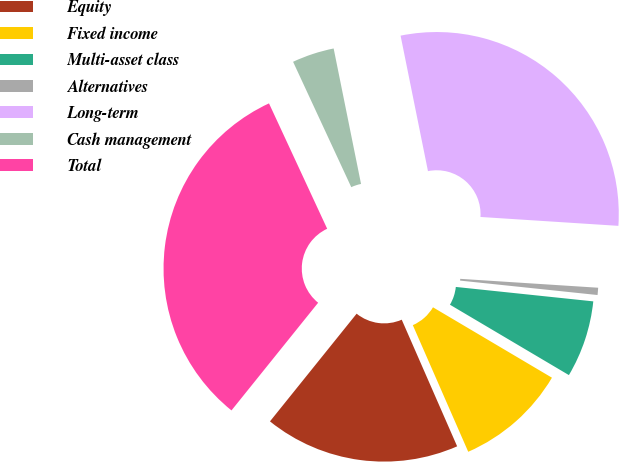<chart> <loc_0><loc_0><loc_500><loc_500><pie_chart><fcel>Equity<fcel>Fixed income<fcel>Multi-asset class<fcel>Alternatives<fcel>Long-term<fcel>Cash management<fcel>Total<nl><fcel>17.35%<fcel>9.93%<fcel>6.84%<fcel>0.64%<fcel>29.2%<fcel>3.74%<fcel>32.3%<nl></chart> 